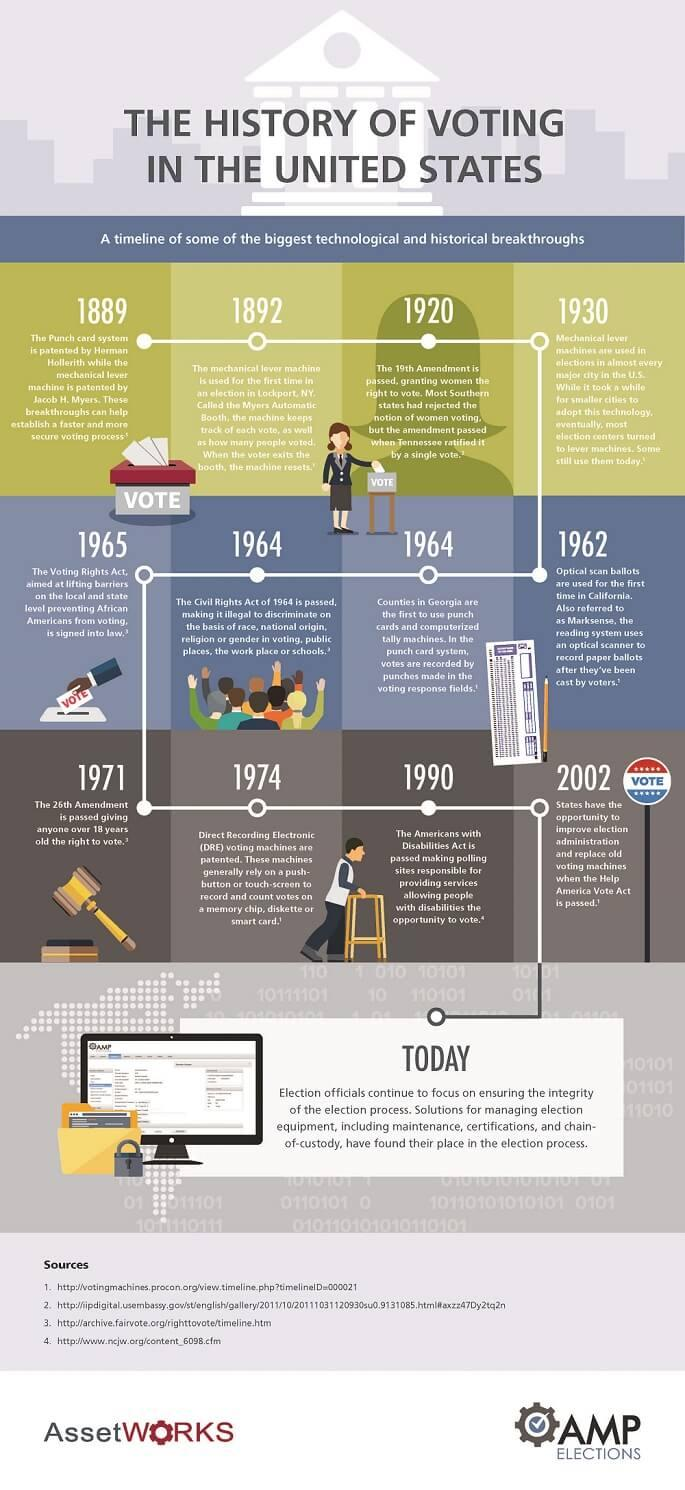Give some essential details in this illustration. The DRE (Direct Recording Electronic) voting machines depend on either a push-button or a touch-screen for recording the votes. What is the Optical Scan Ballots otherwise referred to as? It is known as Marksense. The 19th Amendment, passed in 1920, is a significant milestone in the history of women's suffrage in the United States. The Help America Vote Act was passed in the year 2002. The 26th Amendment was passed in 1971. 